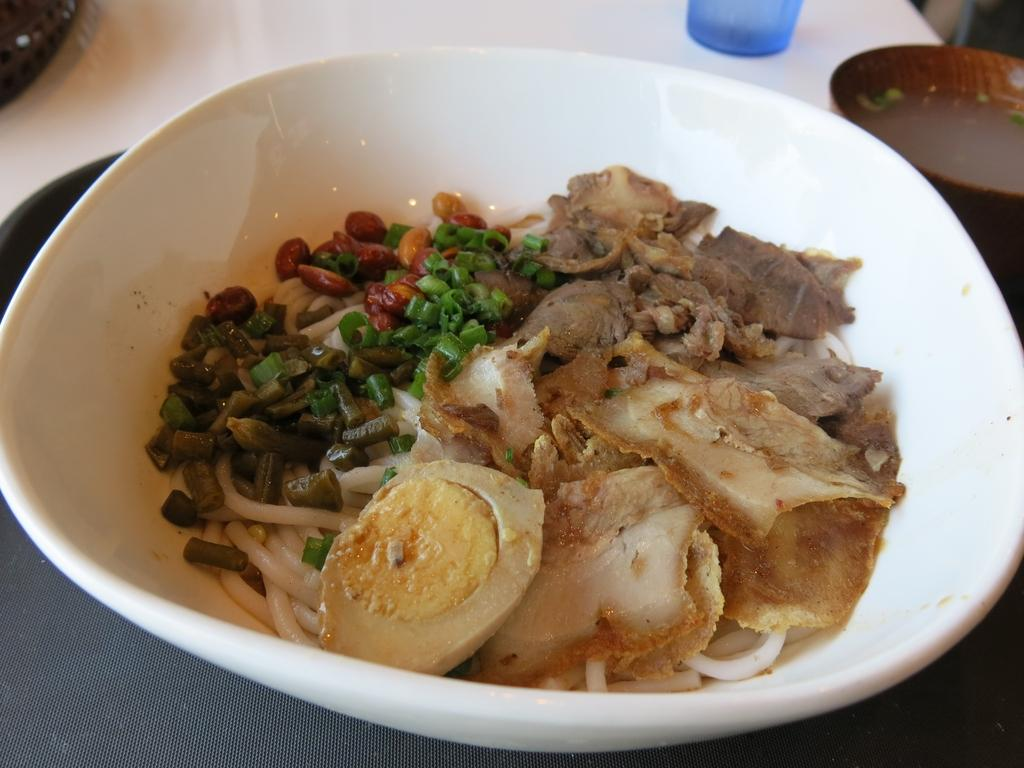What is in the bowl that is visible in the image? There is a bowl with food in the image. What other dish can be seen in the image? There is a plate in the image. What can be found on the table in the image? There are objects on the table in the image. Can you hear the yak crying in the image? There is no yak present in the image, so it cannot be heard crying. 